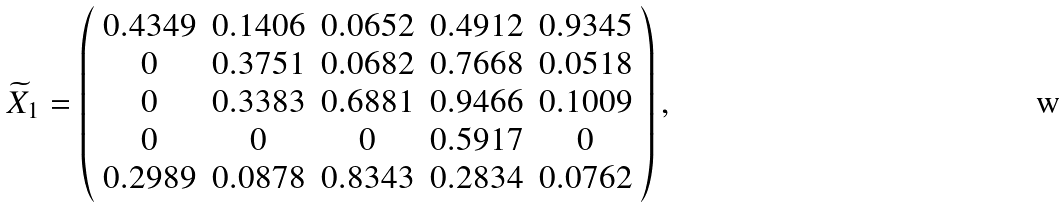Convert formula to latex. <formula><loc_0><loc_0><loc_500><loc_500>\widetilde { X } _ { 1 } = \left ( \begin{array} { c c c c c } 0 . 4 3 4 9 & 0 . 1 4 0 6 & 0 . 0 6 5 2 & 0 . 4 9 1 2 & 0 . 9 3 4 5 \\ 0 & 0 . 3 7 5 1 & 0 . 0 6 8 2 & 0 . 7 6 6 8 & 0 . 0 5 1 8 \\ 0 & 0 . 3 3 8 3 & 0 . 6 8 8 1 & 0 . 9 4 6 6 & 0 . 1 0 0 9 \\ 0 & 0 & 0 & 0 . 5 9 1 7 & 0 \\ 0 . 2 9 8 9 & 0 . 0 8 7 8 & 0 . 8 3 4 3 & 0 . 2 8 3 4 & 0 . 0 7 6 2 \end{array} \right ) ,</formula> 